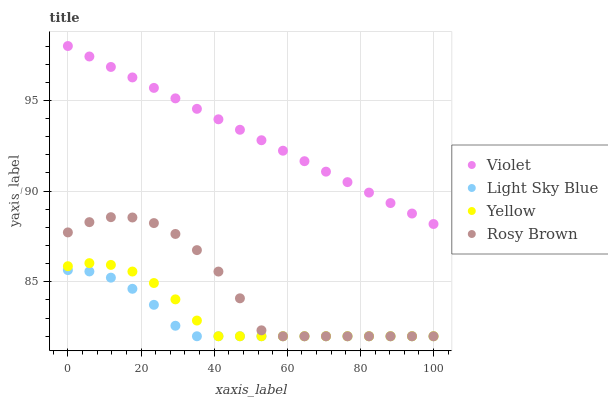Does Light Sky Blue have the minimum area under the curve?
Answer yes or no. Yes. Does Violet have the maximum area under the curve?
Answer yes or no. Yes. Does Yellow have the minimum area under the curve?
Answer yes or no. No. Does Yellow have the maximum area under the curve?
Answer yes or no. No. Is Violet the smoothest?
Answer yes or no. Yes. Is Rosy Brown the roughest?
Answer yes or no. Yes. Is Light Sky Blue the smoothest?
Answer yes or no. No. Is Light Sky Blue the roughest?
Answer yes or no. No. Does Rosy Brown have the lowest value?
Answer yes or no. Yes. Does Violet have the lowest value?
Answer yes or no. No. Does Violet have the highest value?
Answer yes or no. Yes. Does Yellow have the highest value?
Answer yes or no. No. Is Light Sky Blue less than Violet?
Answer yes or no. Yes. Is Violet greater than Light Sky Blue?
Answer yes or no. Yes. Does Yellow intersect Light Sky Blue?
Answer yes or no. Yes. Is Yellow less than Light Sky Blue?
Answer yes or no. No. Is Yellow greater than Light Sky Blue?
Answer yes or no. No. Does Light Sky Blue intersect Violet?
Answer yes or no. No. 